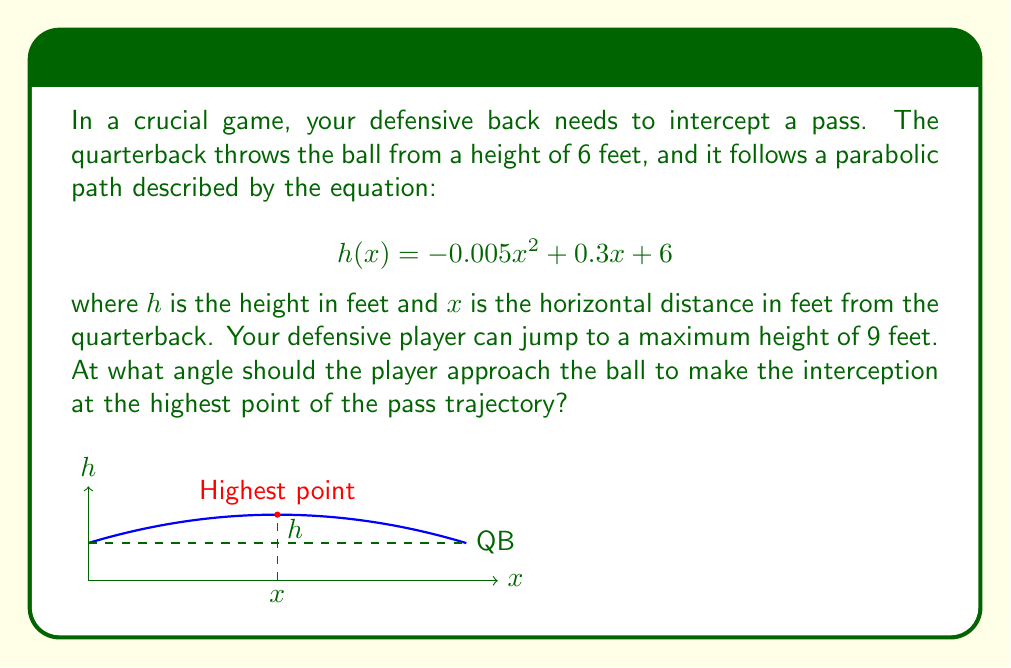Give your solution to this math problem. To solve this problem, we'll follow these steps:

1) First, we need to find the highest point of the pass trajectory. This occurs where the derivative of $h(x)$ is zero.

2) The derivative of $h(x)$ is:
   $$h'(x) = -0.01x + 0.3$$

3) Set $h'(x) = 0$ and solve for $x$:
   $$-0.01x + 0.3 = 0$$
   $$x = 30$$

4) The highest point occurs at $x = 30$ feet. Let's find the height at this point:
   $$h(30) = -0.005(30)^2 + 0.3(30) + 6 = 10.5$$ feet

5) Now, we need to find the angle at which the player should approach the ball. We can use trigonometry for this.

6) The player needs to jump from 6 feet (ground level) to 9 feet (maximum jump height). The horizontal distance from the player to the highest point of the ball is irrelevant for the angle calculation.

7) We can calculate the angle using the arctangent function:
   $$\theta = \arctan(\frac{9 - 6}{30}) = \arctan(\frac{3}{30}) = \arctan(0.1)$$

8) Converting this to degrees:
   $$\theta = \arctan(0.1) \cdot \frac{180}{\pi} \approx 5.71°$$

Therefore, the player should approach the ball at an angle of approximately 5.71° from the horizontal.
Answer: $5.71°$ 